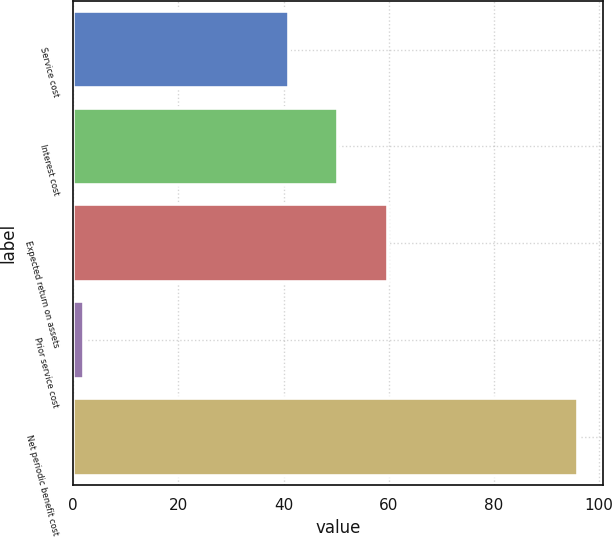Convert chart. <chart><loc_0><loc_0><loc_500><loc_500><bar_chart><fcel>Service cost<fcel>Interest cost<fcel>Expected return on assets<fcel>Prior service cost<fcel>Net periodic benefit cost<nl><fcel>41<fcel>50.4<fcel>59.8<fcel>2<fcel>96<nl></chart> 